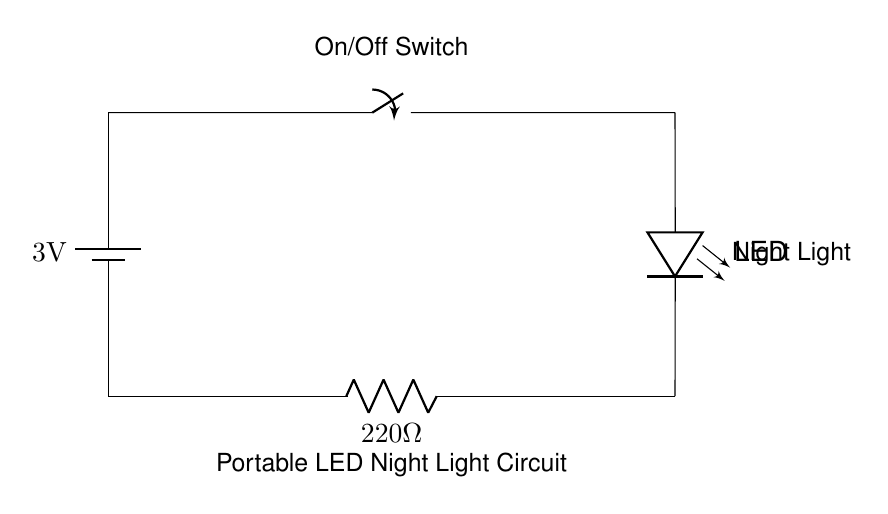What is the voltage of the battery? The circuit diagram shows a battery labeled with a voltage of 3 volts. This indicates the potential difference provided by the battery to the circuit.
Answer: 3 volts What component is used to control the LED? The diagram features a switch that is connected in series with the LED. When the switch is closed, it allows current to flow through the LED, turning it on.
Answer: Switch How many ohms is the resistor? The resistor in the circuit is labeled with a resistance of 220 ohms. This indicates how much the resistor opposes the flow of electric current.
Answer: 220 ohms What happens when the switch is open? When the switch is open, it breaks the circuit, preventing current from flowing to the LED. As a result, the LED will not light up.
Answer: LED off Which way does current flow in the circuit? The current flows from the battery, through the switch, to the LED, and then through the resistor back to the battery. This completes the circuit.
Answer: From battery to LED to resistor 